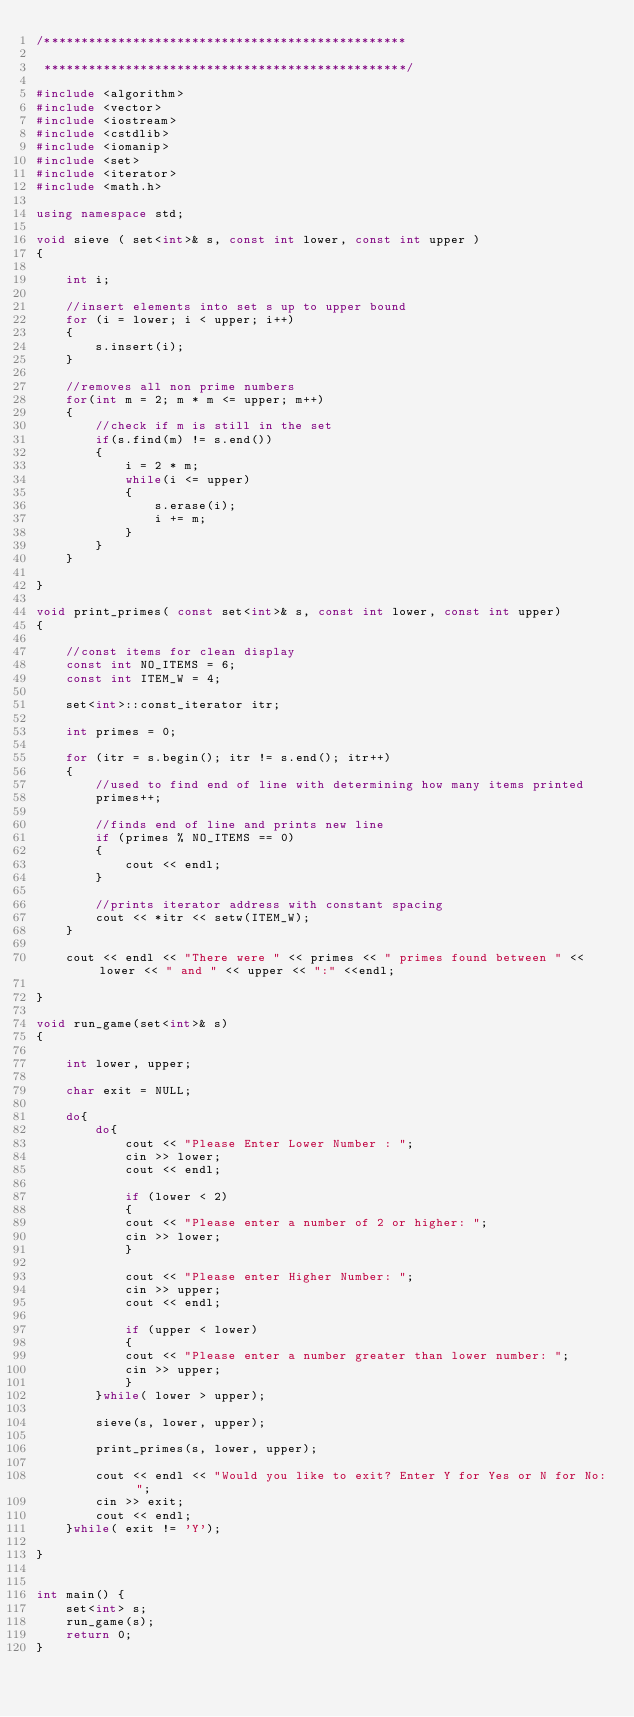Convert code to text. <code><loc_0><loc_0><loc_500><loc_500><_C++_>/*************************************************

 *************************************************/

#include <algorithm>
#include <vector>
#include <iostream>
#include <cstdlib>
#include <iomanip>
#include <set>
#include <iterator>
#include <math.h>

using namespace std;

void sieve ( set<int>& s, const int lower, const int upper )
{
    
    int i;
    
    //insert elements into set s up to upper bound
    for (i = lower; i < upper; i++)
    {
        s.insert(i);
    }
    
    //removes all non prime numbers
    for(int m = 2; m * m <= upper; m++)
    {
        //check if m is still in the set
        if(s.find(m) != s.end())
        {
            i = 2 * m;
            while(i <= upper)
            {
                s.erase(i);
                i += m;
            }
        }
    }
    
}

void print_primes( const set<int>& s, const int lower, const int upper)
{

    //const items for clean display
    const int NO_ITEMS = 6;
    const int ITEM_W = 4;
    
    set<int>::const_iterator itr;
    
    int primes = 0;
    
    for (itr = s.begin(); itr != s.end(); itr++)
    {
        //used to find end of line with determining how many items printed
        primes++;
        
        //finds end of line and prints new line
        if (primes % NO_ITEMS == 0)
        {
            cout << endl;
        }
        
        //prints iterator address with constant spacing
        cout << *itr << setw(ITEM_W);
    }
    
    cout << endl << "There were " << primes << " primes found between " << lower << " and " << upper << ":" <<endl;

}

void run_game(set<int>& s)
{

    int lower, upper;
    
    char exit = NULL;
    
    do{
        do{
            cout << "Please Enter Lower Number : ";
            cin >> lower;
            cout << endl;
        
            if (lower < 2)
            {
            cout << "Please enter a number of 2 or higher: ";
            cin >> lower;
            }
        
            cout << "Please enter Higher Number: ";
            cin >> upper;
            cout << endl;
        
            if (upper < lower)
            {
            cout << "Please enter a number greater than lower number: ";
            cin >> upper;
            }
        }while( lower > upper);

        sieve(s, lower, upper);
        
        print_primes(s, lower, upper);
        
        cout << endl << "Would you like to exit? Enter Y for Yes or N for No: ";
        cin >> exit;
        cout << endl;
    }while( exit != 'Y');
        
}


int main() {
    set<int> s;
    run_game(s);
    return 0;
}

</code> 